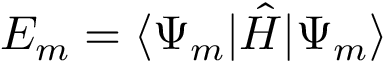Convert formula to latex. <formula><loc_0><loc_0><loc_500><loc_500>E _ { m } = \langle \Psi _ { m } | { \hat { H } } | \Psi _ { m } \rangle</formula> 